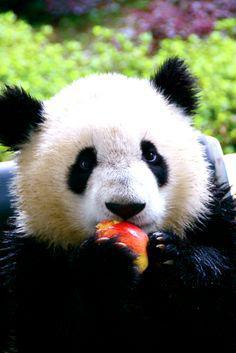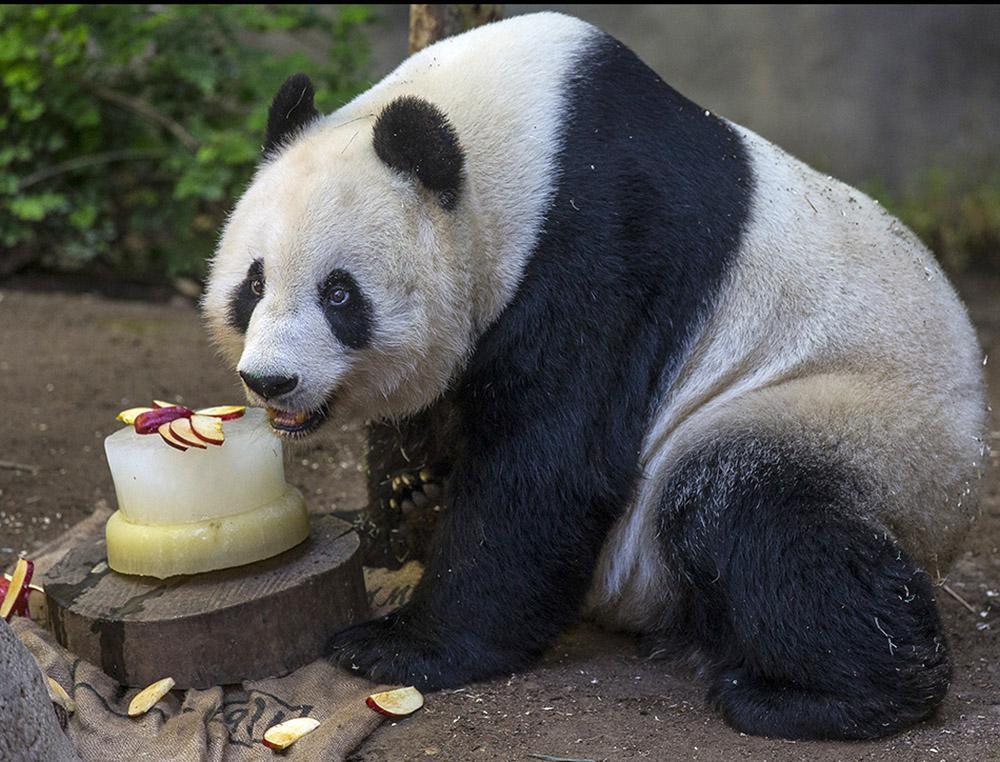The first image is the image on the left, the second image is the image on the right. Considering the images on both sides, is "The panda on the left is looking toward the camera and holding a roundish-shaped food near its mouth." valid? Answer yes or no. Yes. The first image is the image on the left, the second image is the image on the right. Analyze the images presented: Is the assertion "The panda in the image on the left is sitting near an upright post." valid? Answer yes or no. No. 